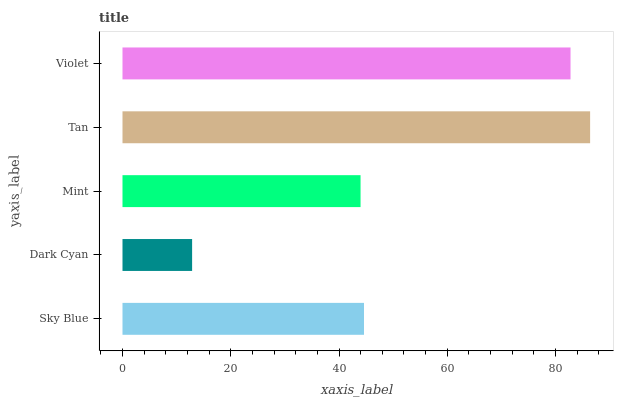Is Dark Cyan the minimum?
Answer yes or no. Yes. Is Tan the maximum?
Answer yes or no. Yes. Is Mint the minimum?
Answer yes or no. No. Is Mint the maximum?
Answer yes or no. No. Is Mint greater than Dark Cyan?
Answer yes or no. Yes. Is Dark Cyan less than Mint?
Answer yes or no. Yes. Is Dark Cyan greater than Mint?
Answer yes or no. No. Is Mint less than Dark Cyan?
Answer yes or no. No. Is Sky Blue the high median?
Answer yes or no. Yes. Is Sky Blue the low median?
Answer yes or no. Yes. Is Mint the high median?
Answer yes or no. No. Is Violet the low median?
Answer yes or no. No. 